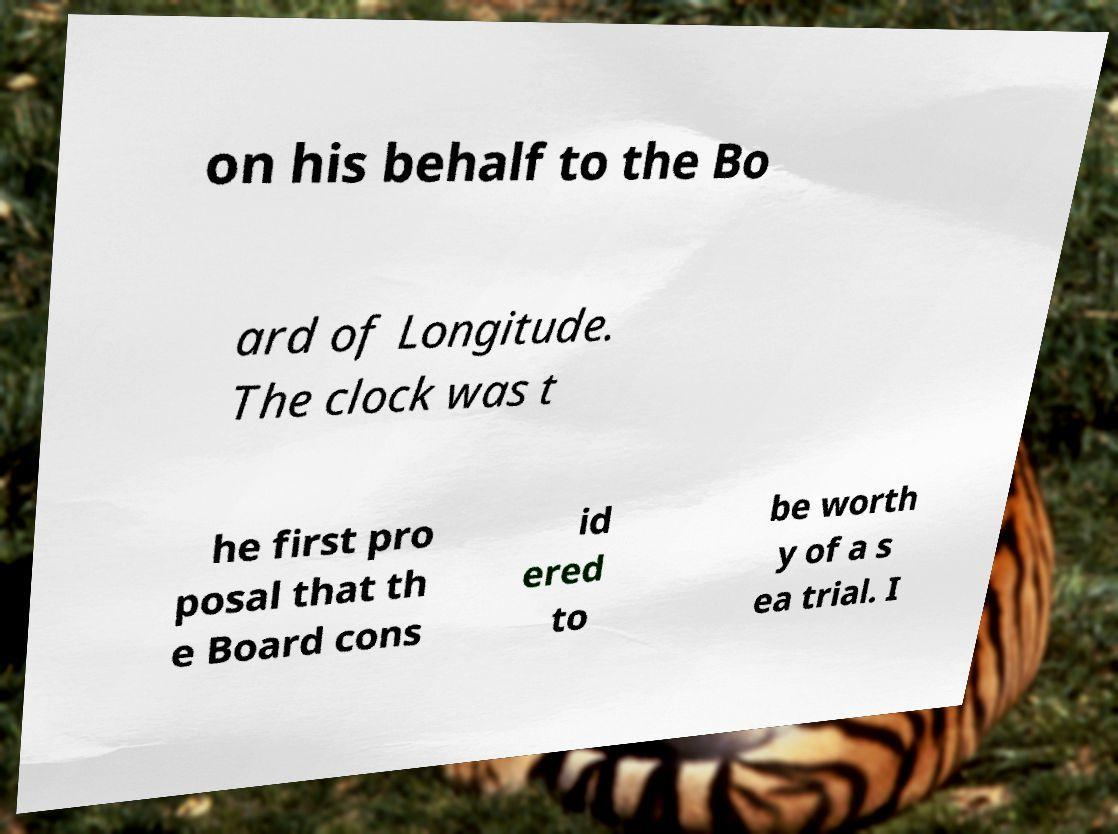For documentation purposes, I need the text within this image transcribed. Could you provide that? on his behalf to the Bo ard of Longitude. The clock was t he first pro posal that th e Board cons id ered to be worth y of a s ea trial. I 